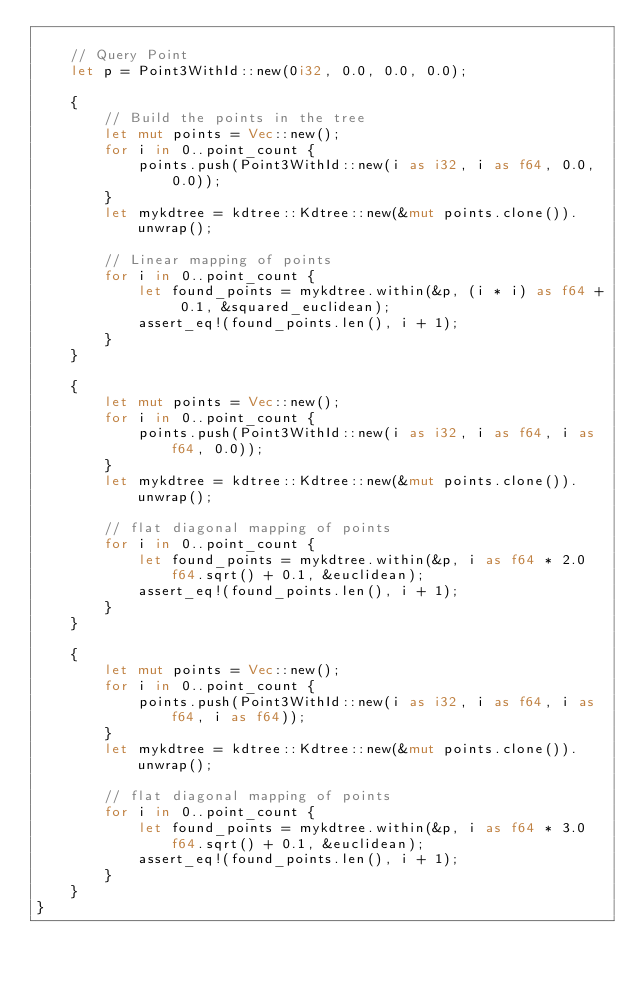Convert code to text. <code><loc_0><loc_0><loc_500><loc_500><_Rust_>
    // Query Point
    let p = Point3WithId::new(0i32, 0.0, 0.0, 0.0);

    {
        // Build the points in the tree
        let mut points = Vec::new();
        for i in 0..point_count {
            points.push(Point3WithId::new(i as i32, i as f64, 0.0, 0.0));
        }
        let mykdtree = kdtree::Kdtree::new(&mut points.clone()).unwrap();

        // Linear mapping of points
        for i in 0..point_count {
            let found_points = mykdtree.within(&p, (i * i) as f64 + 0.1, &squared_euclidean);
            assert_eq!(found_points.len(), i + 1);
        }
    }

    {
        let mut points = Vec::new();
        for i in 0..point_count {
            points.push(Point3WithId::new(i as i32, i as f64, i as f64, 0.0));
        }
        let mykdtree = kdtree::Kdtree::new(&mut points.clone()).unwrap();

        // flat diagonal mapping of points
        for i in 0..point_count {
            let found_points = mykdtree.within(&p, i as f64 * 2.0f64.sqrt() + 0.1, &euclidean);
            assert_eq!(found_points.len(), i + 1);
        }
    }

    {
        let mut points = Vec::new();
        for i in 0..point_count {
            points.push(Point3WithId::new(i as i32, i as f64, i as f64, i as f64));
        }
        let mykdtree = kdtree::Kdtree::new(&mut points.clone()).unwrap();

        // flat diagonal mapping of points
        for i in 0..point_count {
            let found_points = mykdtree.within(&p, i as f64 * 3.0f64.sqrt() + 0.1, &euclidean);
            assert_eq!(found_points.len(), i + 1);
        }
    }
}
</code> 